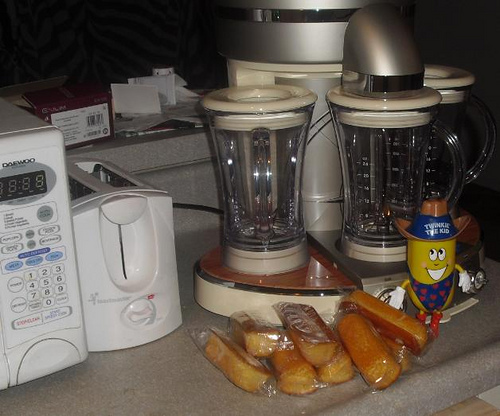<image>Do any of these kitchen appliances appear to be in use at the time of the photo? No, none of the kitchen appliances appear to be in use at the time of the photo. Do any of these kitchen appliances appear to be in use at the time of the photo? None of the kitchen appliances appear to be in use at the time of the photo. 